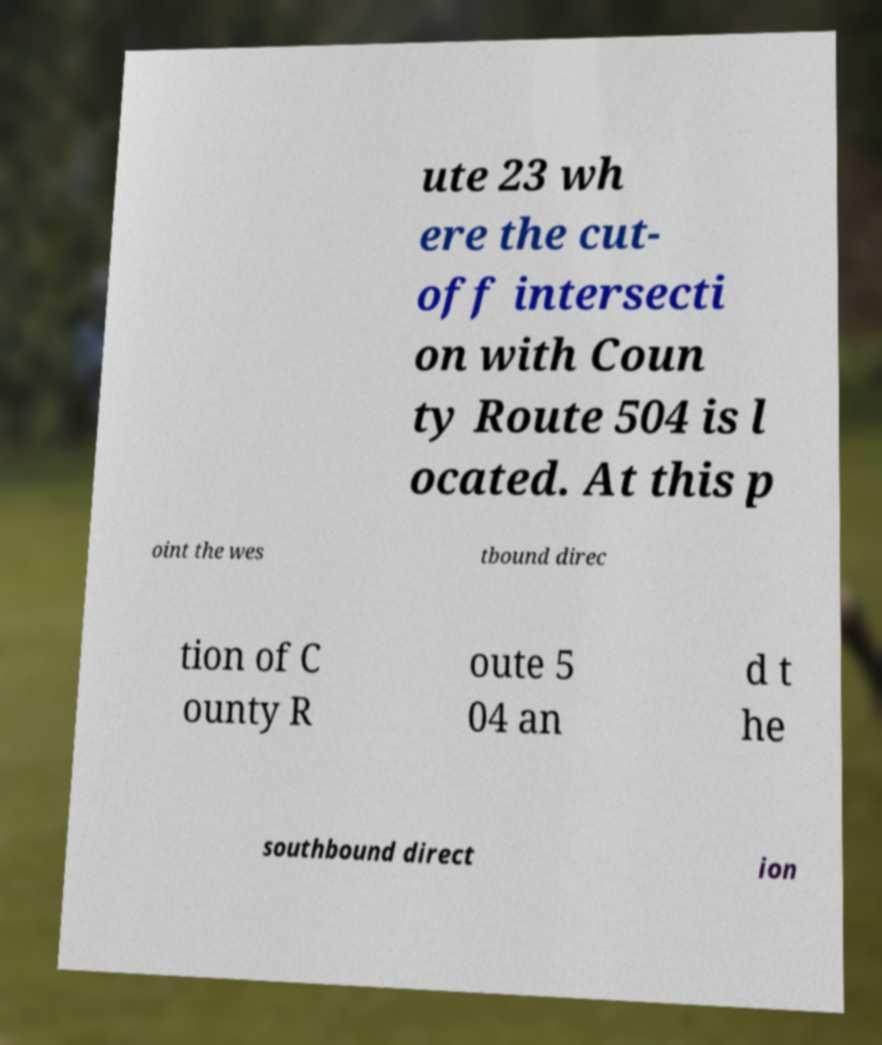Could you assist in decoding the text presented in this image and type it out clearly? ute 23 wh ere the cut- off intersecti on with Coun ty Route 504 is l ocated. At this p oint the wes tbound direc tion of C ounty R oute 5 04 an d t he southbound direct ion 